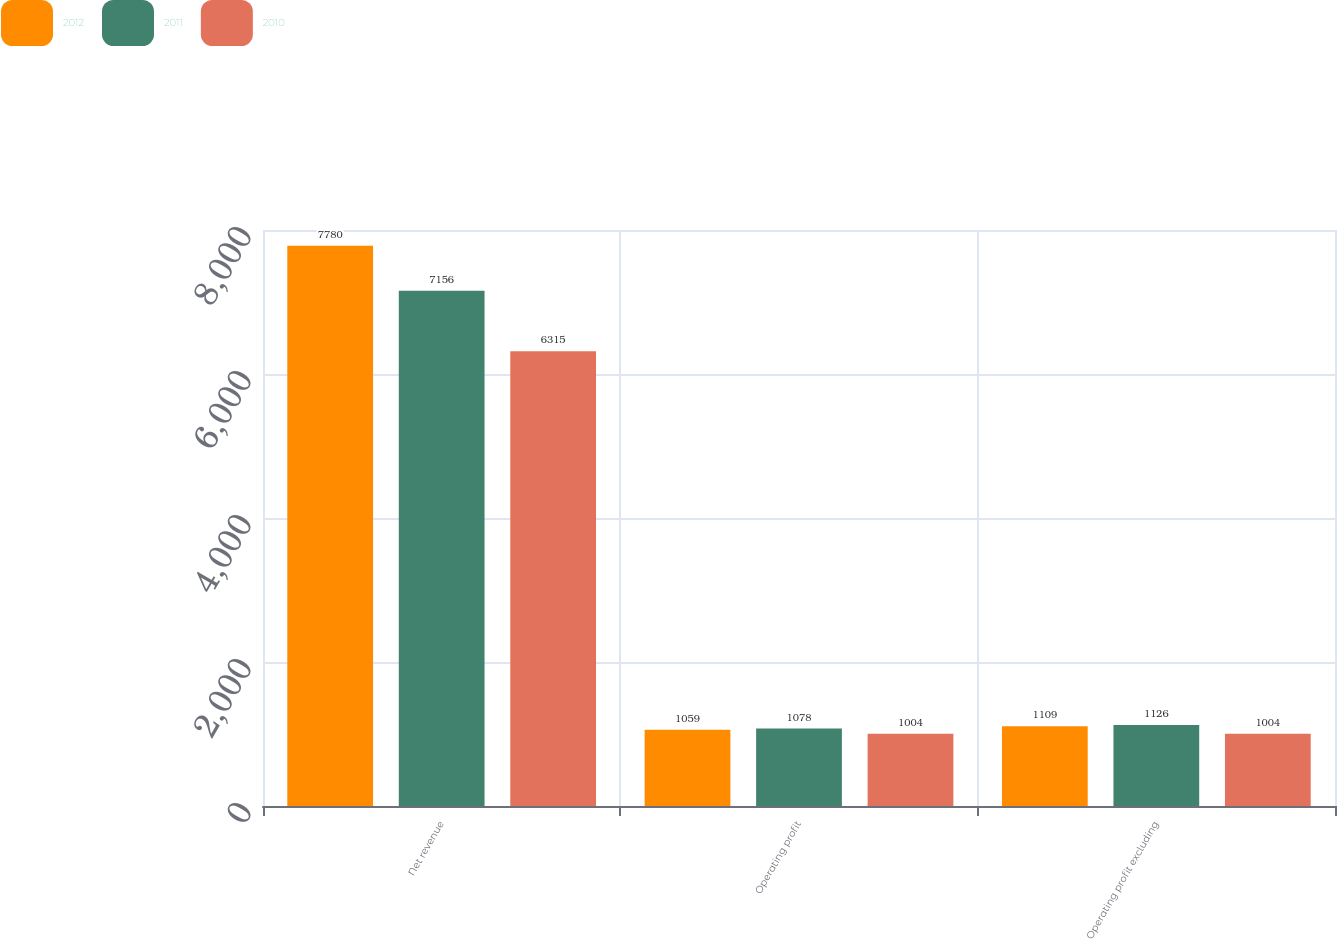<chart> <loc_0><loc_0><loc_500><loc_500><stacked_bar_chart><ecel><fcel>Net revenue<fcel>Operating profit<fcel>Operating profit excluding<nl><fcel>2012<fcel>7780<fcel>1059<fcel>1109<nl><fcel>2011<fcel>7156<fcel>1078<fcel>1126<nl><fcel>2010<fcel>6315<fcel>1004<fcel>1004<nl></chart> 